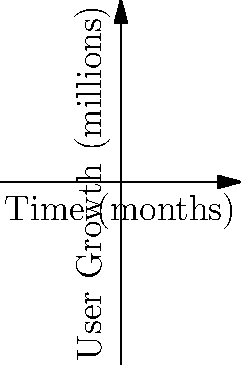The graph shows the user growth rates of three social media platforms over time. Platform A represents the platform currently facing a lawsuit, Platform B is another competitor, and "Our Platform" represents your company's growth. After how many months does your platform's user growth surpass that of Platform A? To find when our platform surpasses Platform A, we need to solve the equation:

$$15\log(x+1) + 2 = 5x + 10$$

Let's solve this step-by-step:

1) Subtract 2 from both sides:
   $$15\log(x+1) = 5x + 8$$

2) Divide both sides by 15:
   $$\log(x+1) = \frac{1}{3}x + \frac{8}{15}$$

3) Apply the exponential function to both sides:
   $$x + 1 = e^{\frac{1}{3}x + \frac{8}{15}}$$

4) Subtract 1 from both sides:
   $$x = e^{\frac{1}{3}x + \frac{8}{15}} - 1$$

This equation cannot be solved algebraically. We need to use numerical methods or graphical analysis.

By plotting both sides of this equation or using a numerical solver, we find that the equation is satisfied when x is approximately 2.76 months.

Therefore, our platform's user growth surpasses Platform A after about 2.76 months.
Answer: 2.76 months 